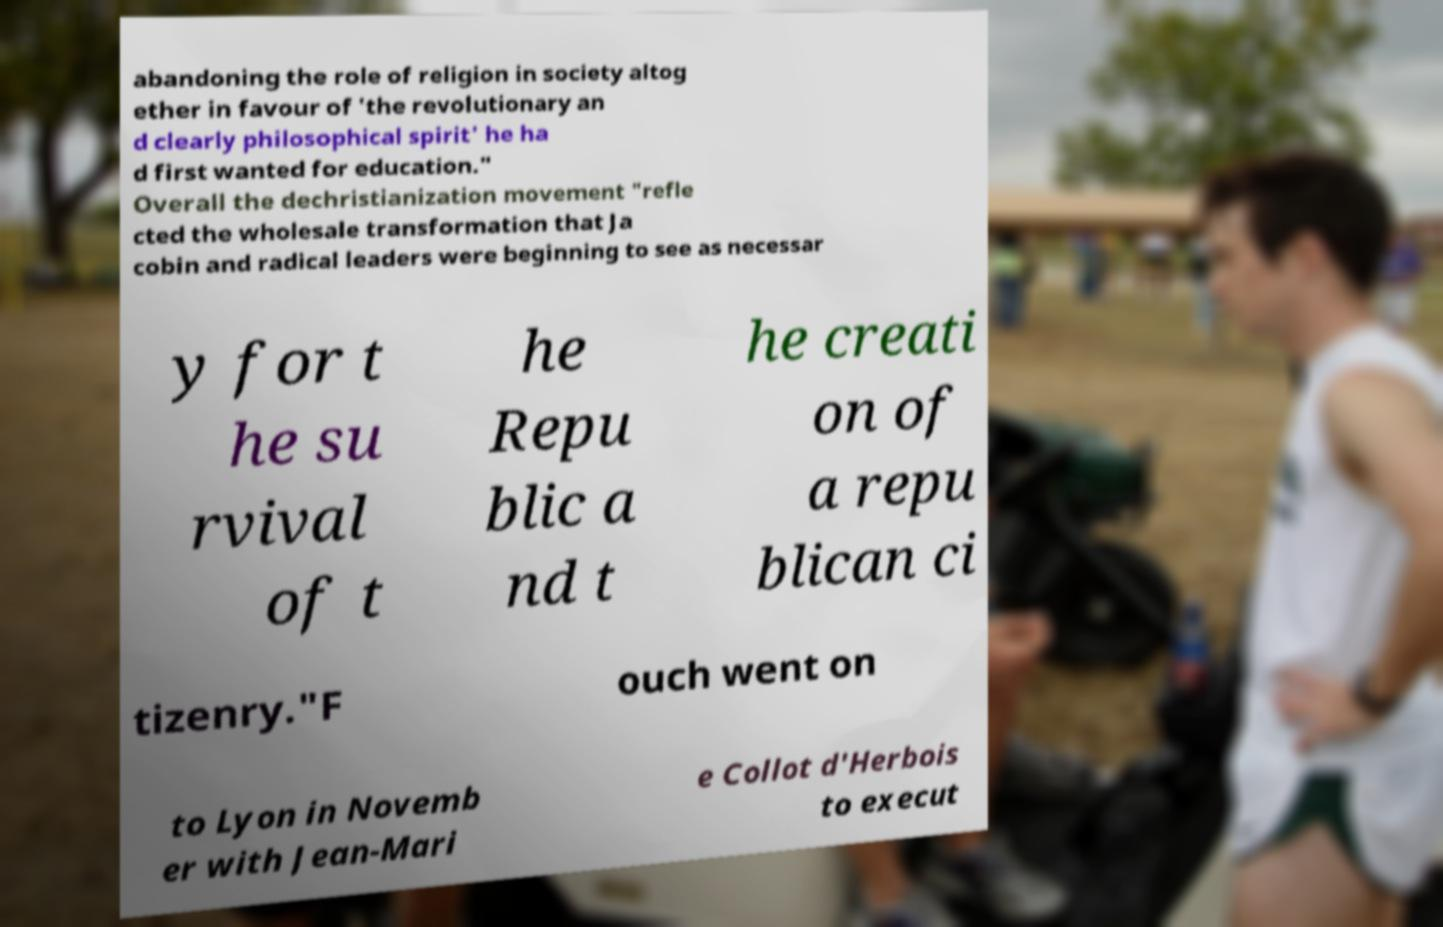Please identify and transcribe the text found in this image. abandoning the role of religion in society altog ether in favour of 'the revolutionary an d clearly philosophical spirit' he ha d first wanted for education." Overall the dechristianization movement "refle cted the wholesale transformation that Ja cobin and radical leaders were beginning to see as necessar y for t he su rvival of t he Repu blic a nd t he creati on of a repu blican ci tizenry."F ouch went on to Lyon in Novemb er with Jean-Mari e Collot d'Herbois to execut 